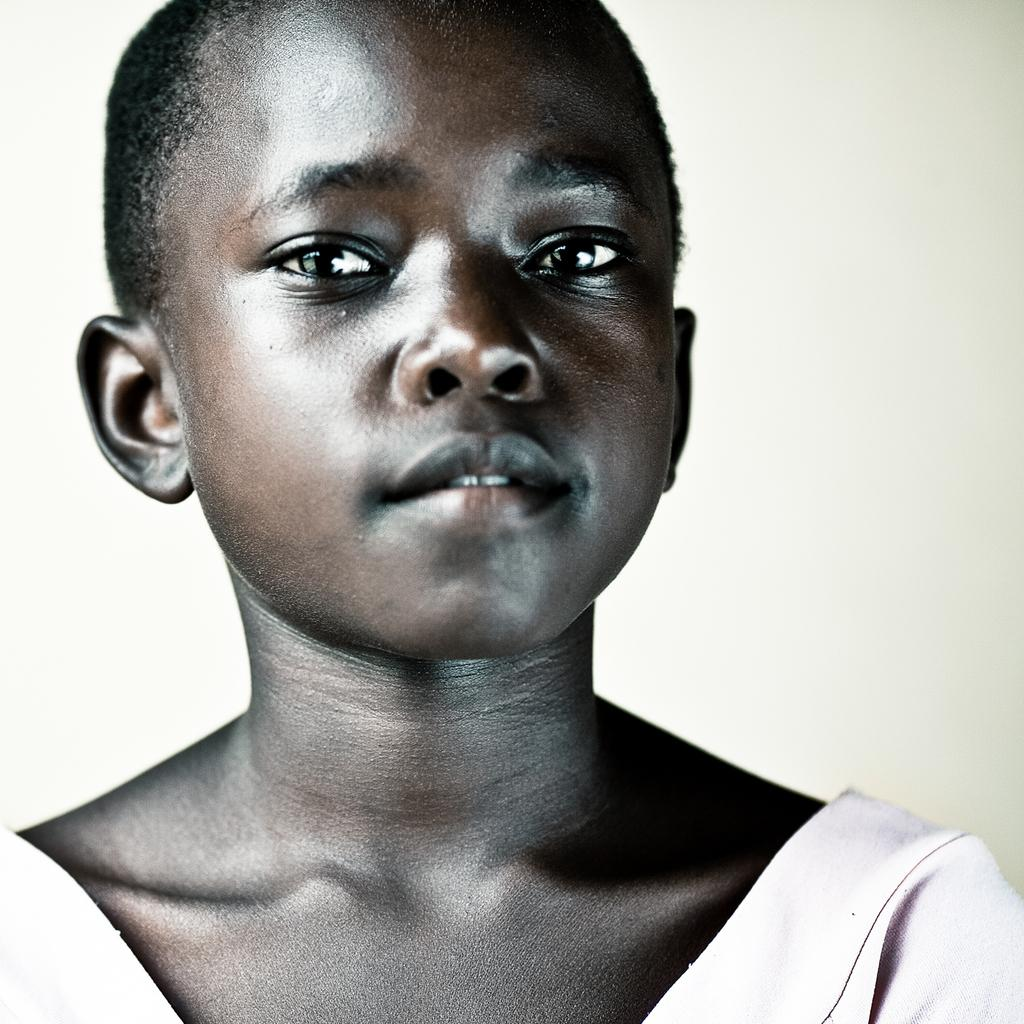What is the main subject of the image? There is a person in the image. What is the person wearing? The person is wearing a white dress. What can be seen in the background of the image? The background of the image is white. How many apples are being held by the person in the image? There are no apples visible in the image. What sense is being stimulated by the person in the image? The provided facts do not mention any sensory stimulation, so it cannot be determined from the image. 